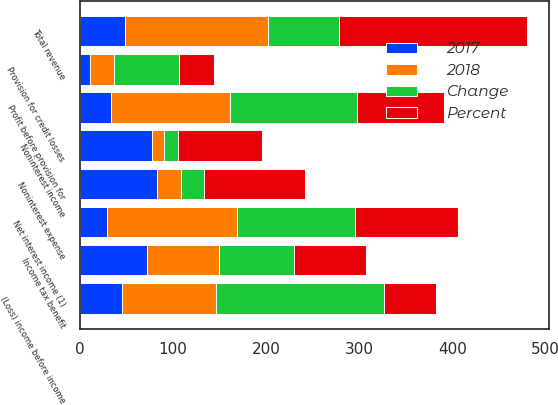Convert chart to OTSL. <chart><loc_0><loc_0><loc_500><loc_500><stacked_bar_chart><ecel><fcel>Net interest income (1)<fcel>Noninterest income<fcel>Total revenue<fcel>Noninterest expense<fcel>Profit before provision for<fcel>Provision for credit losses<fcel>(Loss) income before income<fcel>Income tax benefit<nl><fcel>2017<fcel>29<fcel>78<fcel>49<fcel>83<fcel>34<fcel>11<fcel>45<fcel>72<nl><fcel>Percent<fcel>111<fcel>91<fcel>202<fcel>109<fcel>93<fcel>37<fcel>56<fcel>77<nl><fcel>2018<fcel>140<fcel>13<fcel>153<fcel>26<fcel>127<fcel>26<fcel>101<fcel>77<nl><fcel>Change<fcel>126<fcel>14<fcel>76<fcel>24<fcel>137<fcel>70<fcel>180<fcel>81<nl></chart> 